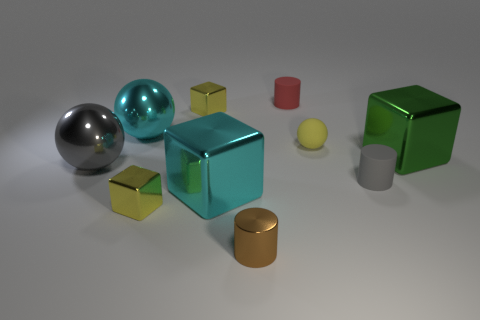Do the tiny brown cylinder and the big green object in front of the yellow ball have the same material?
Keep it short and to the point. Yes. Is the number of yellow matte spheres behind the yellow rubber sphere less than the number of large brown cylinders?
Make the answer very short. No. How many other objects are the same shape as the small brown shiny thing?
Your response must be concise. 2. Are there any other things of the same color as the small metallic cylinder?
Ensure brevity in your answer.  No. There is a small matte ball; does it have the same color as the small metallic block behind the green shiny thing?
Offer a very short reply. Yes. How many other things are the same size as the gray rubber cylinder?
Keep it short and to the point. 5. How many balls are brown shiny things or large things?
Give a very brief answer. 2. Is the shape of the cyan object behind the big cyan metal cube the same as  the big gray object?
Provide a short and direct response. Yes. Are there more tiny yellow metallic cubes that are on the right side of the tiny rubber ball than small red matte objects?
Keep it short and to the point. No. The metal cylinder that is the same size as the red object is what color?
Keep it short and to the point. Brown. 